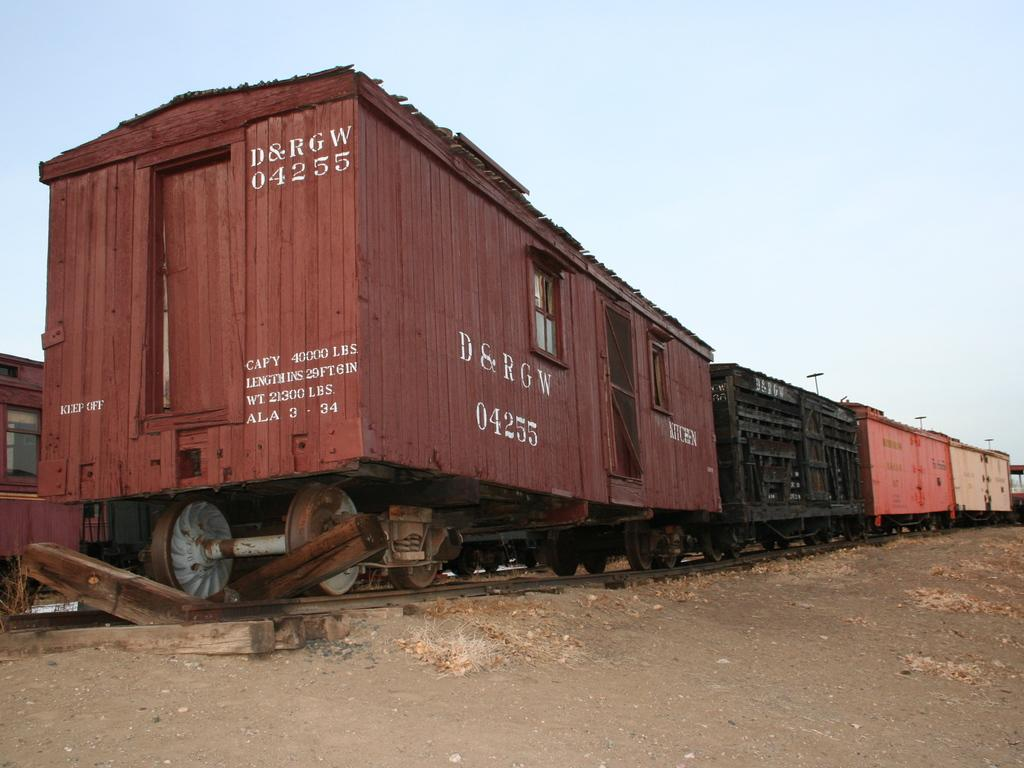<image>
Relay a brief, clear account of the picture shown. Red containers with one which says 04255 on the front. 